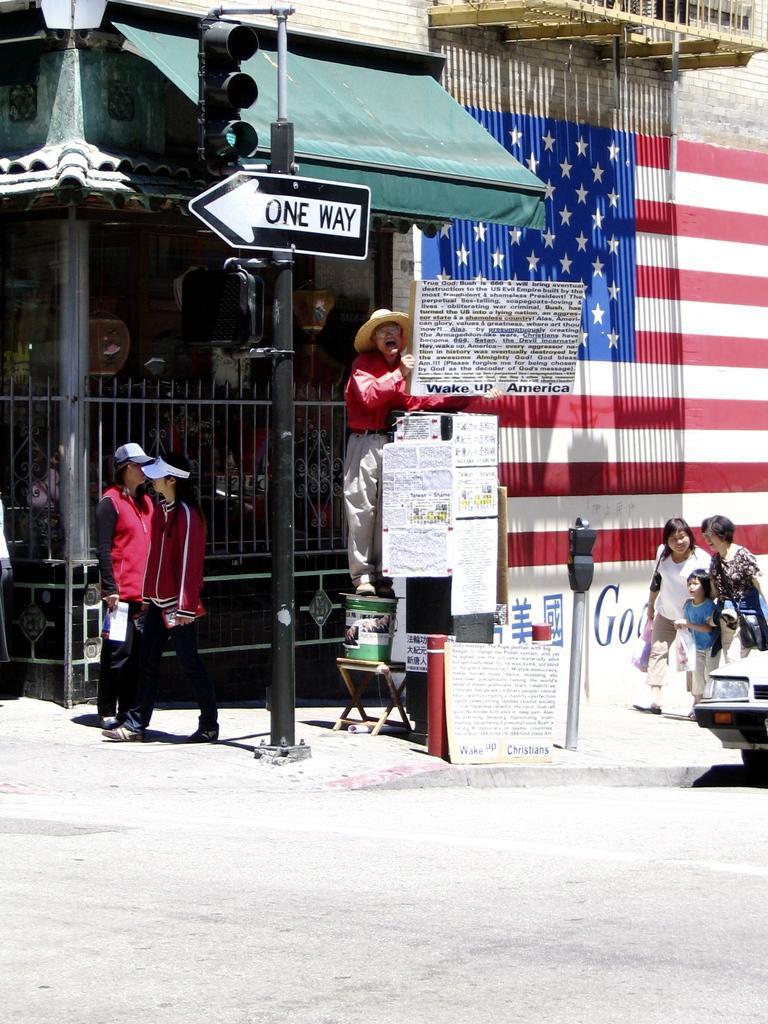In one or two sentences, can you explain what this image depicts? In the center of the image we can see a person is standing on some objects and he is wearing a hat and he is holding one board with some text. And we can see one person is standing and a few people are walking and they are holding some objects. Among them, we can see two persons are wearing caps. On the right side of the image, we can see the part of a car on the road. In the background, there is a wall with some flag painting on it. And we can see poles, railings, one signboard, traffic signal, posters and a few other objects. 